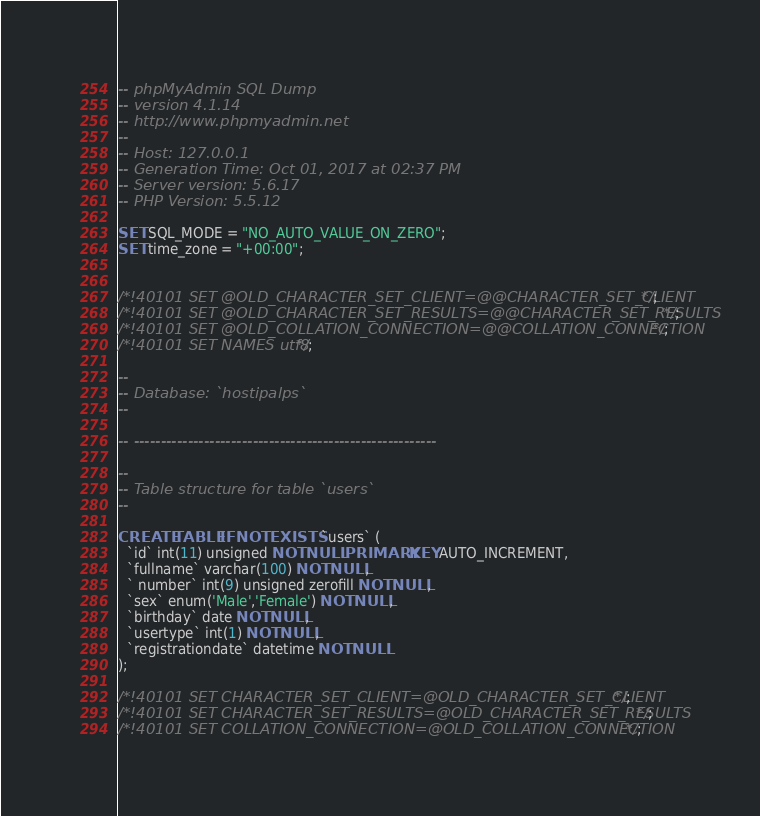Convert code to text. <code><loc_0><loc_0><loc_500><loc_500><_SQL_>-- phpMyAdmin SQL Dump
-- version 4.1.14
-- http://www.phpmyadmin.net
--
-- Host: 127.0.0.1
-- Generation Time: Oct 01, 2017 at 02:37 PM
-- Server version: 5.6.17
-- PHP Version: 5.5.12

SET SQL_MODE = "NO_AUTO_VALUE_ON_ZERO";
SET time_zone = "+00:00";


/*!40101 SET @OLD_CHARACTER_SET_CLIENT=@@CHARACTER_SET_CLIENT */;
/*!40101 SET @OLD_CHARACTER_SET_RESULTS=@@CHARACTER_SET_RESULTS */;
/*!40101 SET @OLD_COLLATION_CONNECTION=@@COLLATION_CONNECTION */;
/*!40101 SET NAMES utf8 */;

--
-- Database: `hostipalps`
--

-- --------------------------------------------------------

--
-- Table structure for table `users`
--

CREATE TABLE IF NOT EXISTS `users` (
  `id` int(11) unsigned NOT NULL PRIMARY KEY AUTO_INCREMENT,
  `fullname` varchar(100) NOT NULL,
  ` number` int(9) unsigned zerofill NOT NULL,
  `sex` enum('Male','Female') NOT NULL,
  `birthday` date NOT NULL,
  `usertype` int(1) NOT NULL,
  `registrationdate` datetime NOT NULL
);

/*!40101 SET CHARACTER_SET_CLIENT=@OLD_CHARACTER_SET_CLIENT */;
/*!40101 SET CHARACTER_SET_RESULTS=@OLD_CHARACTER_SET_RESULTS */;
/*!40101 SET COLLATION_CONNECTION=@OLD_COLLATION_CONNECTION */;
</code> 